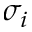Convert formula to latex. <formula><loc_0><loc_0><loc_500><loc_500>\sigma _ { i }</formula> 